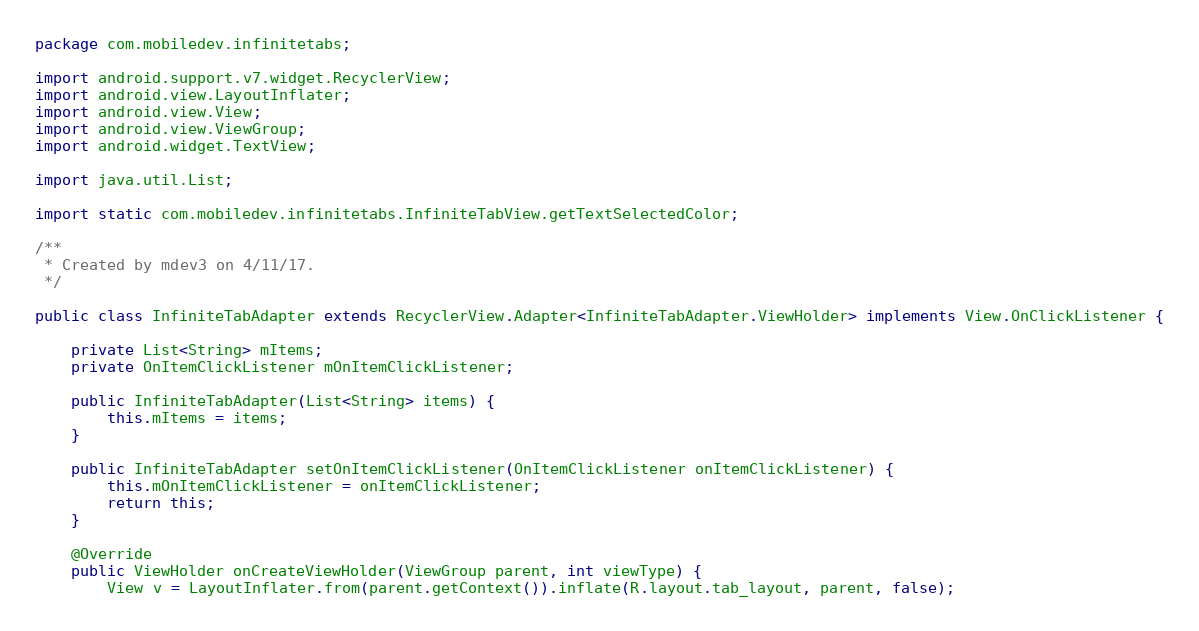<code> <loc_0><loc_0><loc_500><loc_500><_Java_>package com.mobiledev.infinitetabs;

import android.support.v7.widget.RecyclerView;
import android.view.LayoutInflater;
import android.view.View;
import android.view.ViewGroup;
import android.widget.TextView;

import java.util.List;

import static com.mobiledev.infinitetabs.InfiniteTabView.getTextSelectedColor;

/**
 * Created by mdev3 on 4/11/17.
 */

public class InfiniteTabAdapter extends RecyclerView.Adapter<InfiniteTabAdapter.ViewHolder> implements View.OnClickListener {

    private List<String> mItems;
    private OnItemClickListener mOnItemClickListener;

    public InfiniteTabAdapter(List<String> items) {
        this.mItems = items;
    }

    public InfiniteTabAdapter setOnItemClickListener(OnItemClickListener onItemClickListener) {
        this.mOnItemClickListener = onItemClickListener;
        return this;
    }

    @Override
    public ViewHolder onCreateViewHolder(ViewGroup parent, int viewType) {
        View v = LayoutInflater.from(parent.getContext()).inflate(R.layout.tab_layout, parent, false);</code> 